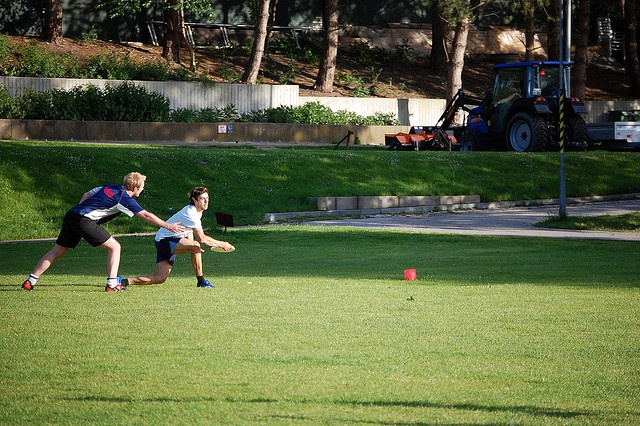Describe the objects in this image and their specific colors. I can see truck in black, navy, gray, and ivory tones, people in black, white, navy, and gray tones, people in black, white, maroon, and gray tones, truck in black, darkgray, gray, and navy tones, and frisbee in black, olive, darkgreen, and white tones in this image. 